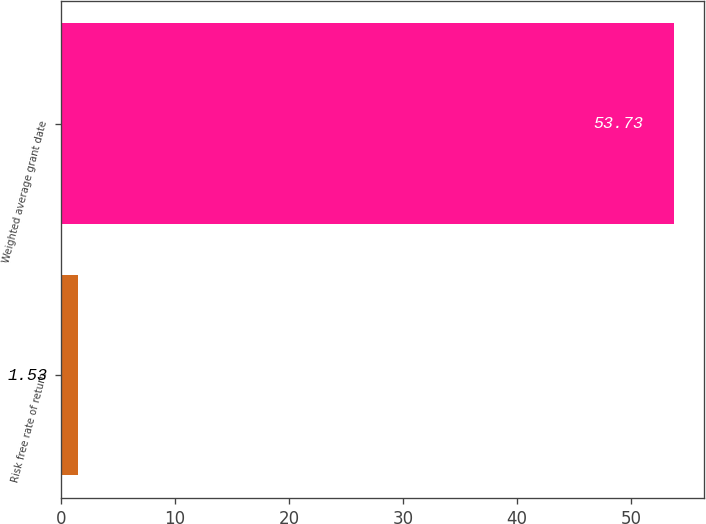Convert chart to OTSL. <chart><loc_0><loc_0><loc_500><loc_500><bar_chart><fcel>Risk free rate of return<fcel>Weighted average grant date<nl><fcel>1.53<fcel>53.73<nl></chart> 